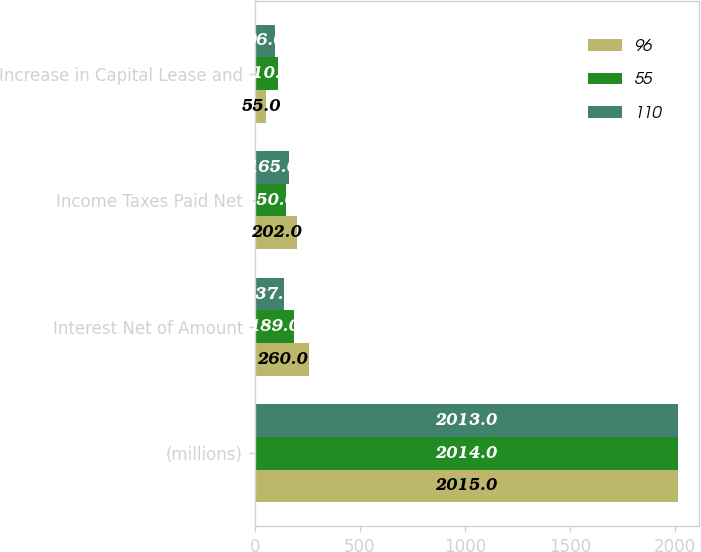Convert chart. <chart><loc_0><loc_0><loc_500><loc_500><stacked_bar_chart><ecel><fcel>(millions)<fcel>Interest Net of Amount<fcel>Income Taxes Paid Net<fcel>Increase in Capital Lease and<nl><fcel>96<fcel>2015<fcel>260<fcel>202<fcel>55<nl><fcel>55<fcel>2014<fcel>189<fcel>150<fcel>110<nl><fcel>110<fcel>2013<fcel>137<fcel>165<fcel>96<nl></chart> 